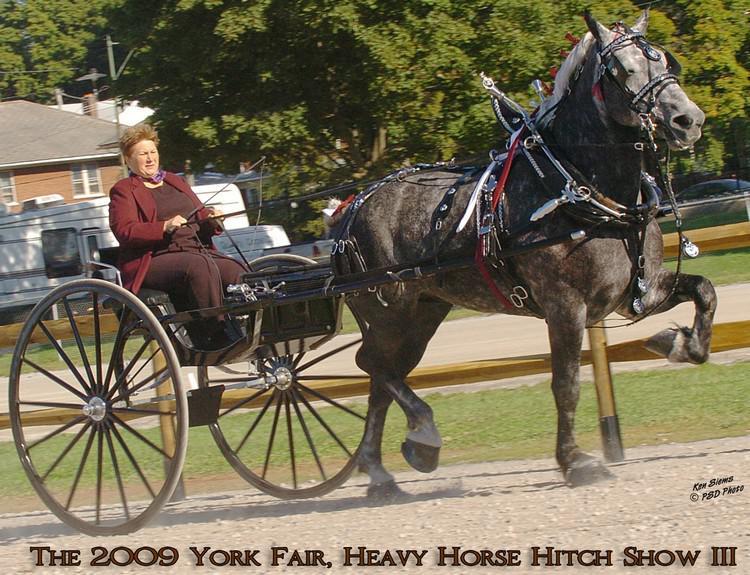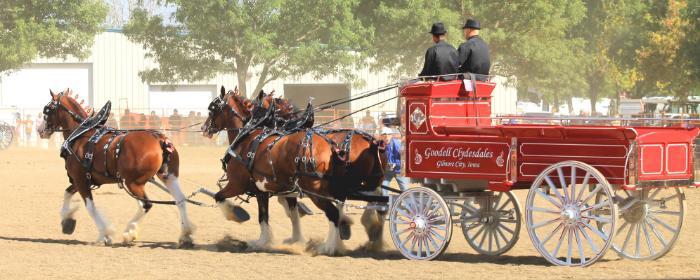The first image is the image on the left, the second image is the image on the right. Considering the images on both sides, is "The horses in the image on the right are pulling a red carriage." valid? Answer yes or no. Yes. The first image is the image on the left, the second image is the image on the right. Examine the images to the left and right. Is the description "One image shows a wagon being pulled by four horses." accurate? Answer yes or no. No. 